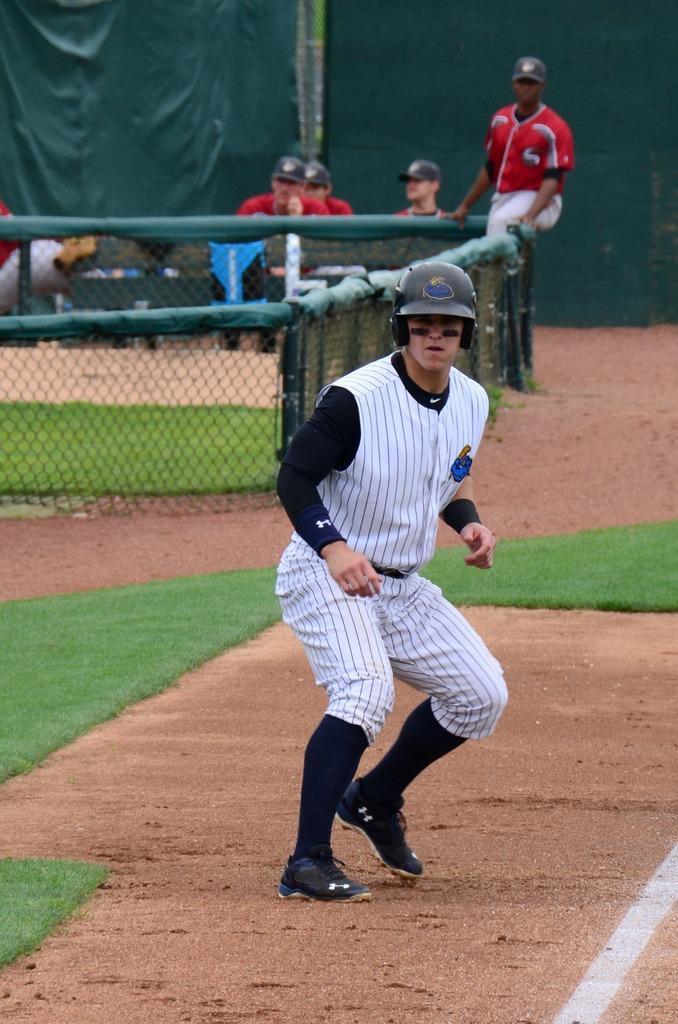How would you summarize this image in a sentence or two? In this image, I can see the man standing. He wore a helmet, T-shirt, trouser, socks and shoes. This is the grass. This looks like a fence. I can see few people sitting. This looks like a cloth hanging. 